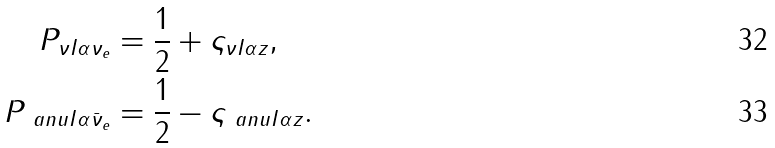Convert formula to latex. <formula><loc_0><loc_0><loc_500><loc_500>P _ { \nu I { \alpha } \nu _ { e } } & = \frac { 1 } { 2 } + \varsigma _ { \nu I { \alpha } z } , \\ P _ { \ a n u I { \alpha } \bar { \nu } _ { e } } & = \frac { 1 } { 2 } - \varsigma _ { \ a n u I { \alpha } z } .</formula> 